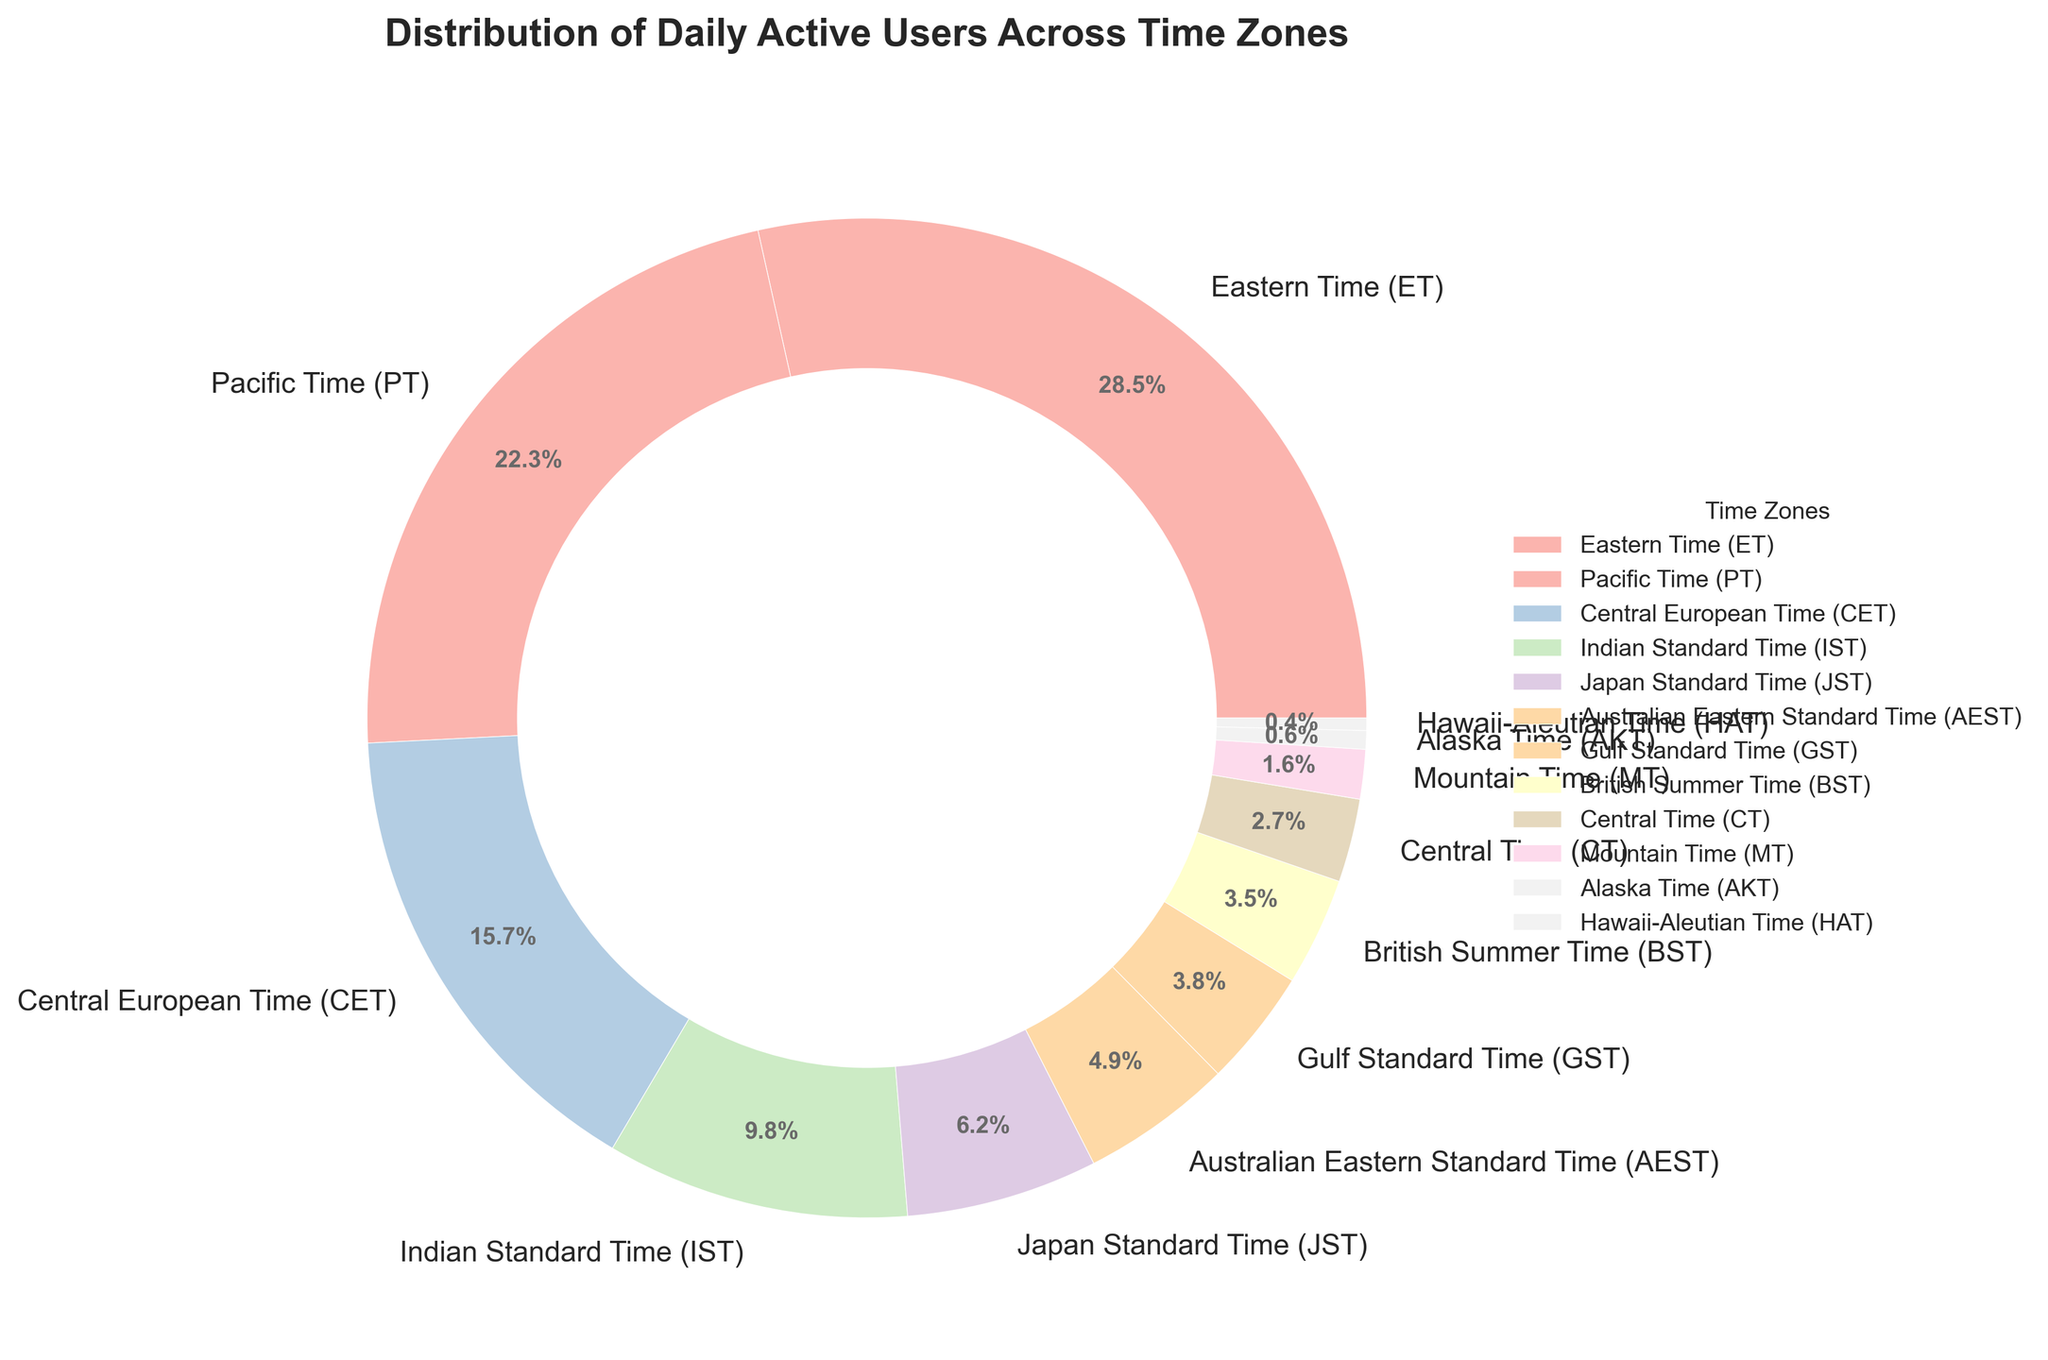What percentage of daily active users fall under the Eastern Time (ET) zone? The pie chart shows that the ET zone makes up 28.5% of the daily active users.
Answer: 28.5% Which time zone has the smallest percentage of daily active users? The pie chart indicates that the Hawaii-Aleutian Time (HAT) zone has the smallest percentage at 0.4%.
Answer: Hawaii-Aleutian Time (HAT) How do the daily active users in Central Time (CT) compare to those in Mountain Time (MT)? The pie chart shows that the CT zone has 2.7% of daily active users, which is greater than the MT zone with 1.6%.
Answer: Central Time (CT) What's the combined percentage of daily active users in Pacific Time (PT) and Central European Time (CET)? The PT zone has 22.3% and the CET zone has 15.7%. Adding these together gives 22.3% + 15.7% = 38.0%.
Answer: 38.0% If you sum the percentages of daily active users in the Indian Standard Time (IST), Japan Standard Time (JST), and Australian Eastern Standard Time (AEST) zones, what is the total? The IST zone has 9.8%, the JST zone has 6.2%, and the AEST zone has 4.9%. Summing these: 9.8% + 6.2% + 4.9% = 20.9%.
Answer: 20.9% Are there more daily active users in the British Summer Time (BST) zone or the Gulf Standard Time (GST) zone? The pie chart shows that the BST zone has 3.5% while the GST zone has 3.8%. Therefore, GST has more daily active users.
Answer: Gulf Standard Time (GST) What is the visual attribute used to differentiate the time zones in the pie chart? The time zones in the pie chart are differentiated by distinct color segments.
Answer: Colors What's the difference in the percentage of daily active users between Eastern Time (ET) and Central Time (CT)? The ET zone has 28.5% and the CT zone has 2.7%. The difference is 28.5% - 2.7% = 25.8%.
Answer: 25.8% What percentage of daily active users are in the US time zones combined, considering ET, PT, CT, MT, AKT, and HAT? Summing the percentages: ET (28.5%) + PT (22.3%) + CT (2.7%) + MT (1.6%) + AKT (0.6%) + HAT (0.4%) = 56.1%.
Answer: 56.1% Which time zone represents approximately 5% of daily active users, as shown in the pie chart? The pie chart indicates that the Australian Eastern Standard Time (AEST) zone closely represents 4.9%, which is approximately 5%.
Answer: Australian Eastern Standard Time (AEST) 